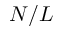Convert formula to latex. <formula><loc_0><loc_0><loc_500><loc_500>N / L</formula> 